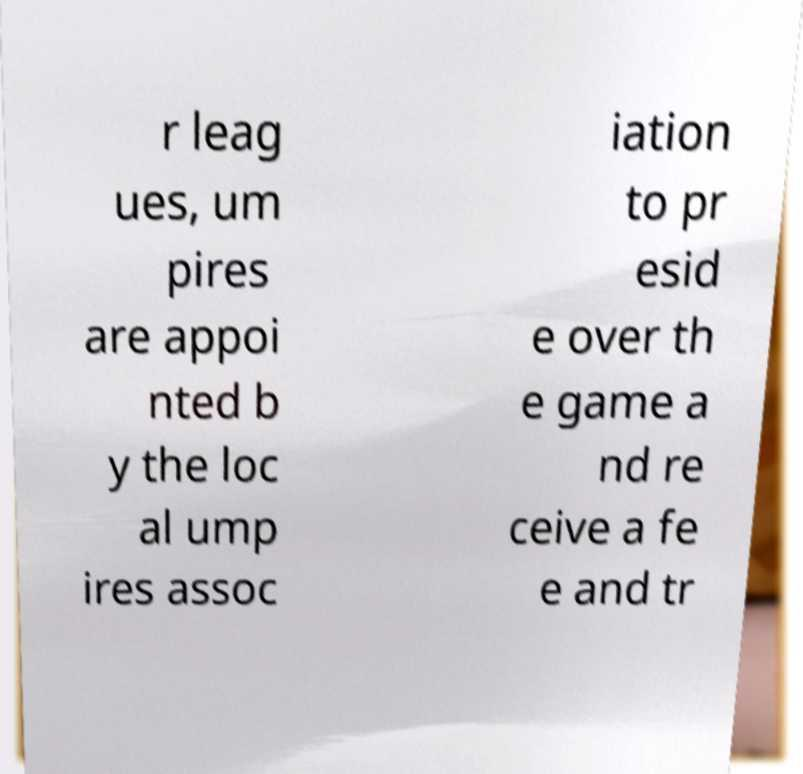Can you accurately transcribe the text from the provided image for me? r leag ues, um pires are appoi nted b y the loc al ump ires assoc iation to pr esid e over th e game a nd re ceive a fe e and tr 